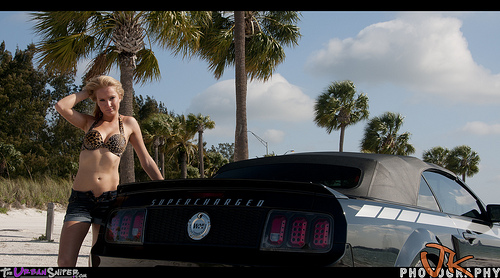<image>
Can you confirm if the car is to the left of the woman? Yes. From this viewpoint, the car is positioned to the left side relative to the woman. Is the car in front of the palm tree? Yes. The car is positioned in front of the palm tree, appearing closer to the camera viewpoint. 